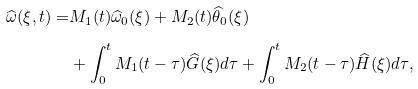<formula> <loc_0><loc_0><loc_500><loc_500>\widehat { \omega } ( \xi , t ) = & M _ { 1 } ( t ) \widehat { \omega } _ { 0 } ( \xi ) + M _ { 2 } ( t ) \widehat { \theta } _ { 0 } ( \xi ) \\ & + \int _ { 0 } ^ { t } M _ { 1 } ( t - \tau ) \widehat { G } ( \xi ) d \tau + \int _ { 0 } ^ { t } M _ { 2 } ( t - \tau ) \widehat { H } ( \xi ) d \tau ,</formula> 